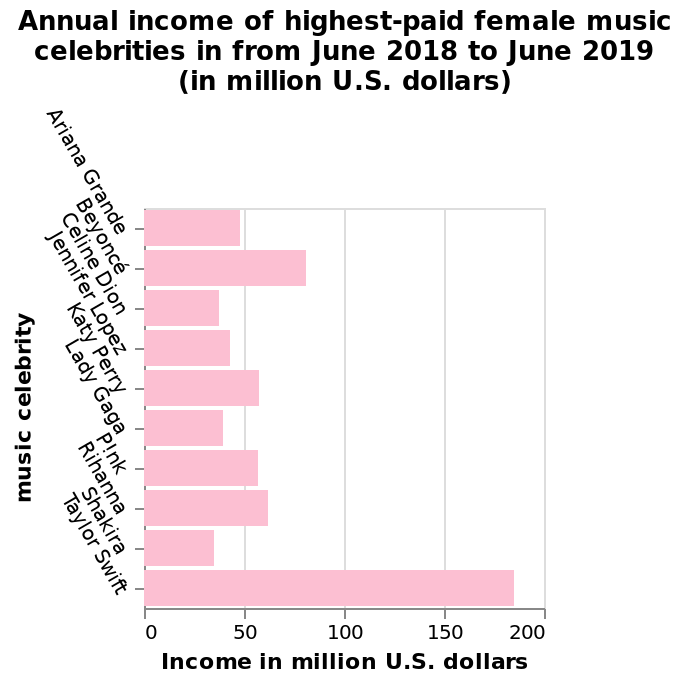<image>
What is the unit of measurement for the x-axis in the bar chart? The unit of measurement for the x-axis in the bar chart is million U.S. dollars. Who is at the top of the y-axis in the bar chart?  Taylor Swift is at the top of the y-axis in the bar chart. What is the time period for which the income is calculated in the bar chart?  The income is calculated from June 2018 to June 2019 in the bar chart. 